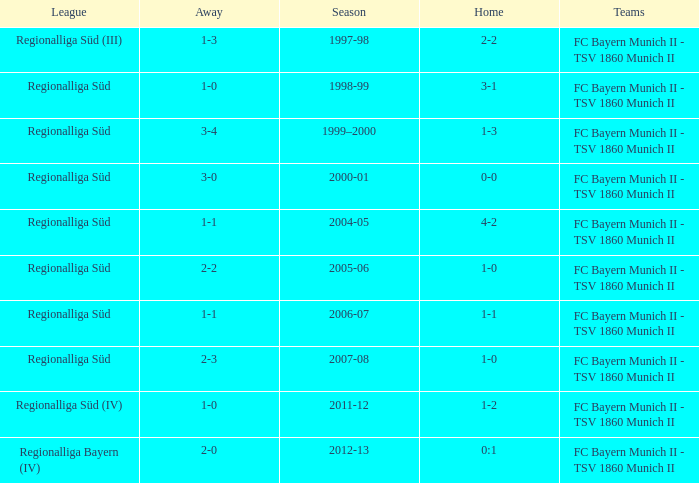What league has a 3-1 home? Regionalliga Süd. 